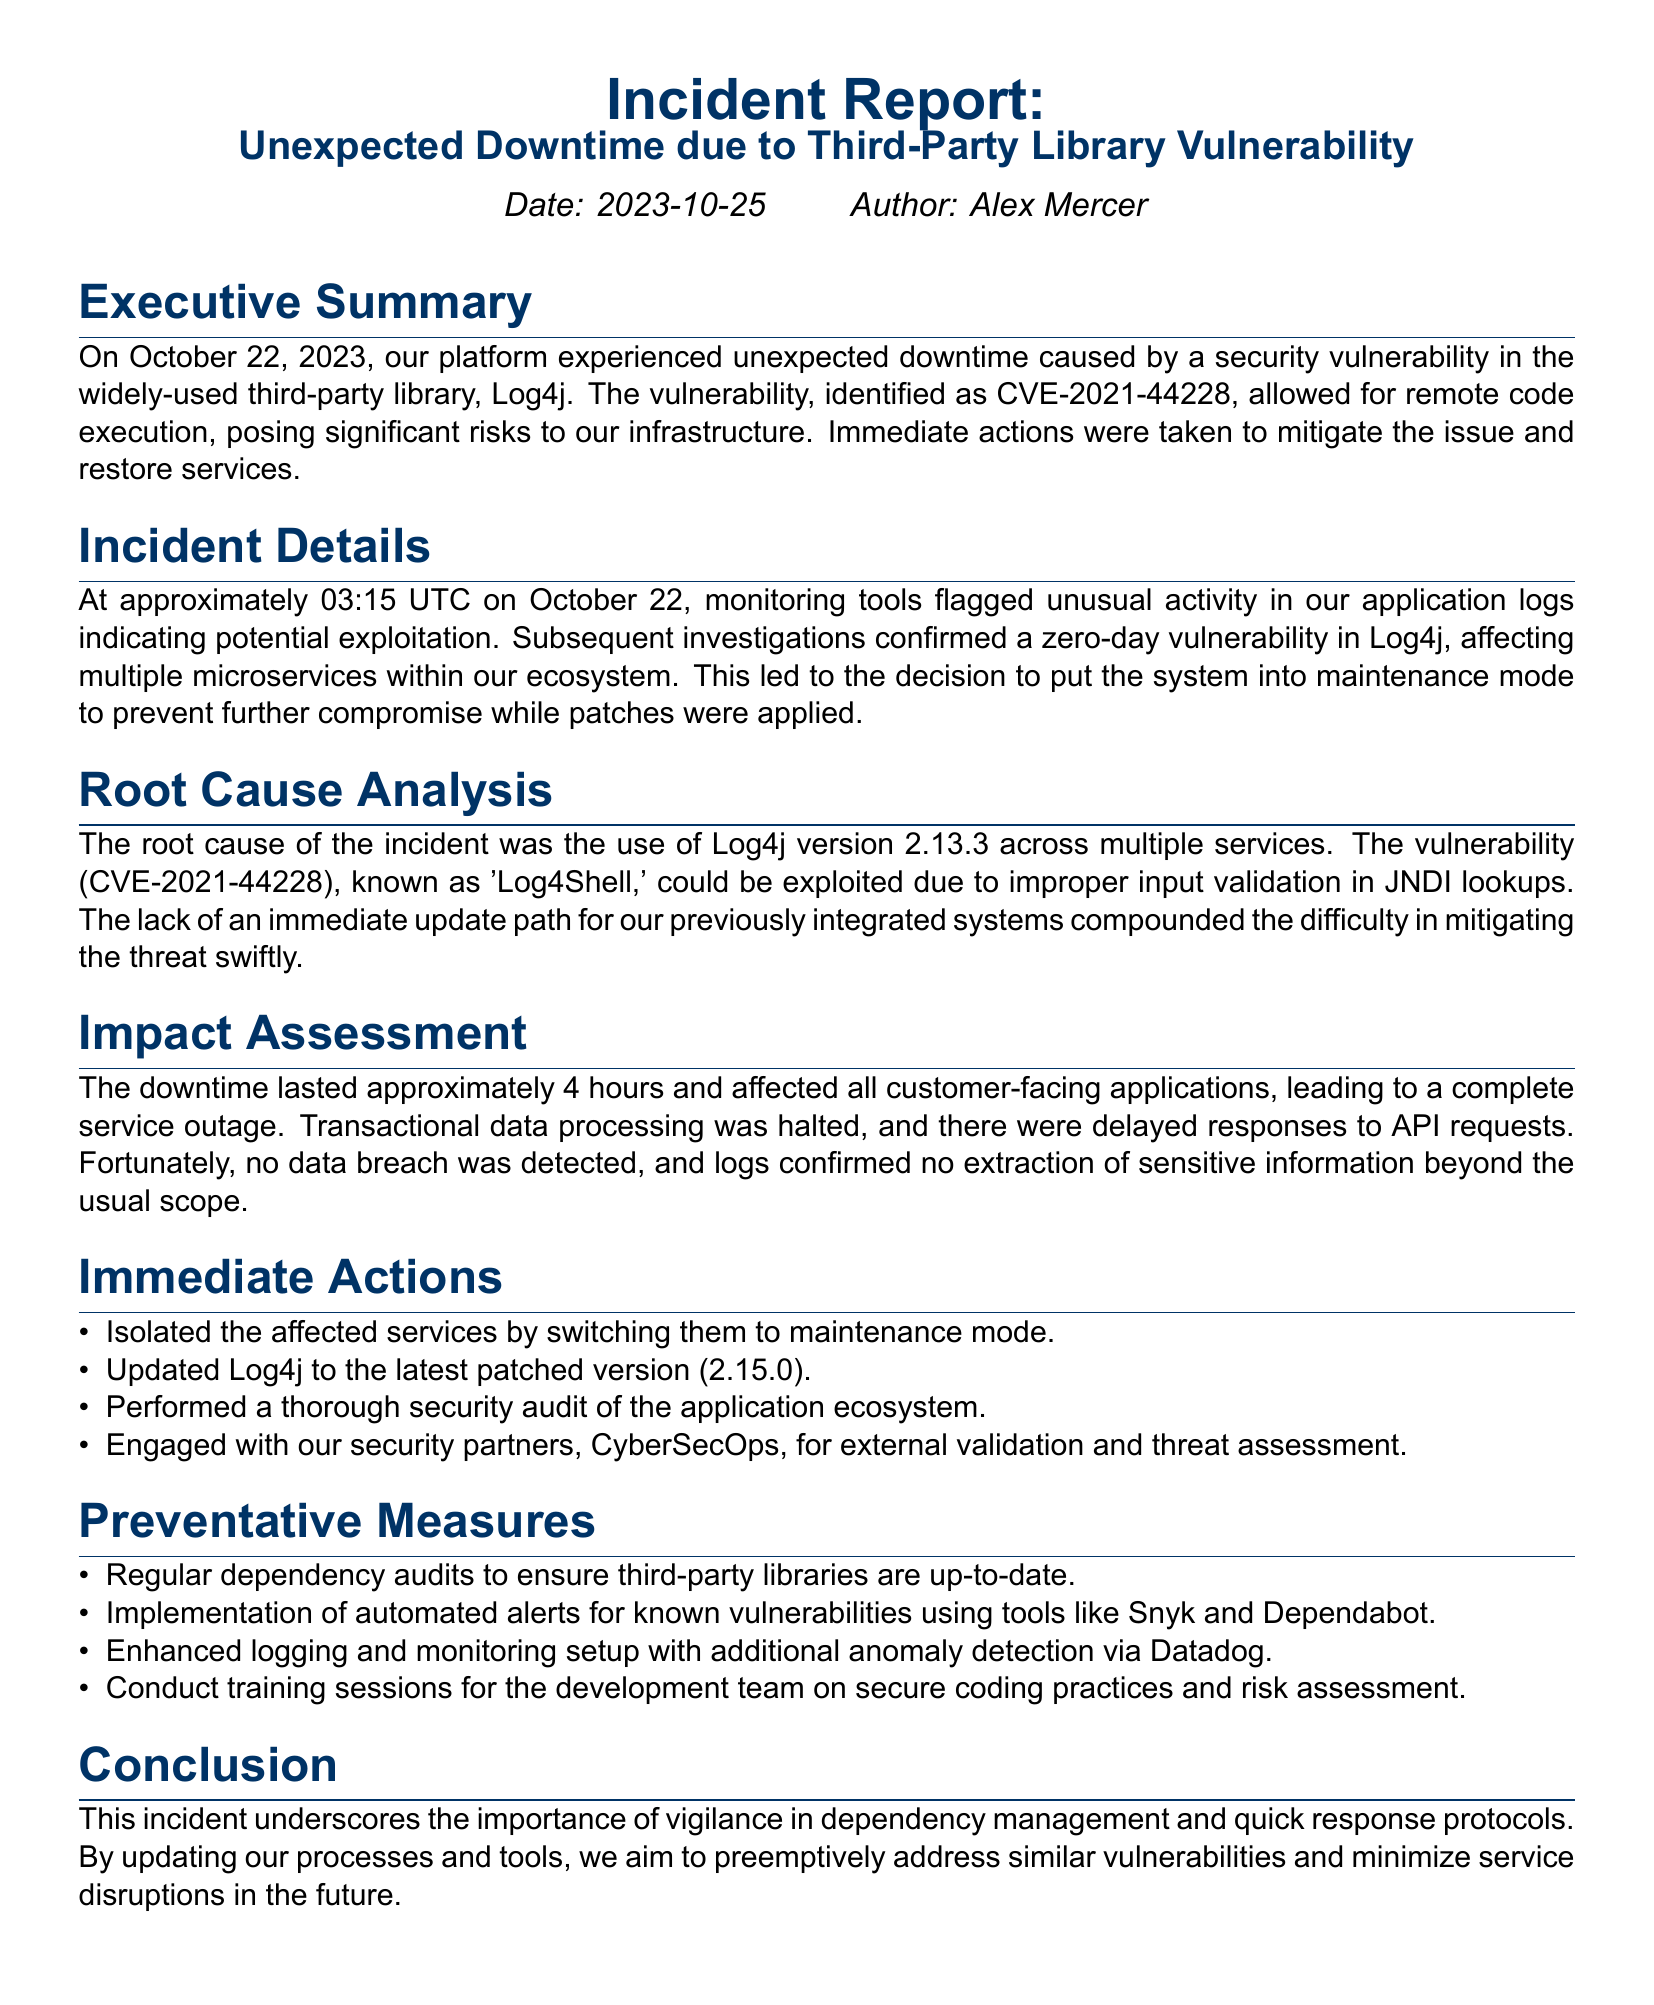What was the date of the incident? The date of the incident is clearly stated in the document as October 22, 2023.
Answer: October 22, 2023 What was the vulnerability identified? The document specifies the vulnerability identified as CVE-2021-44228.
Answer: CVE-2021-44228 How long did the downtime last? The downtime duration is mentioned as approximately 4 hours in the impact assessment section.
Answer: 4 hours What version of Log4j was updated? The document indicates that Log4j was updated to version 2.15.0 during immediate actions.
Answer: 2.15.0 What type of tool is Snyk? The section on preventative measures mentions Snyk as a tool for automated alerts for known vulnerabilities.
Answer: Tool for automated alerts What was the root cause of the incident? The document specifies the root cause as the use of Log4j version 2.13.3 across multiple services.
Answer: Log4j version 2.13.3 Which organization was engaged for external validation? The document mentions that CyberSecOps was engaged for external validation and threat assessment.
Answer: CyberSecOps What training is suggested for the development team? The preventative measures section states that training sessions on secure coding practices and risk assessment are suggested.
Answer: Secure coding practices and risk assessment What action was taken to isolate affected services? The report states that affected services were switched to maintenance mode to isolate them.
Answer: Maintenance mode 